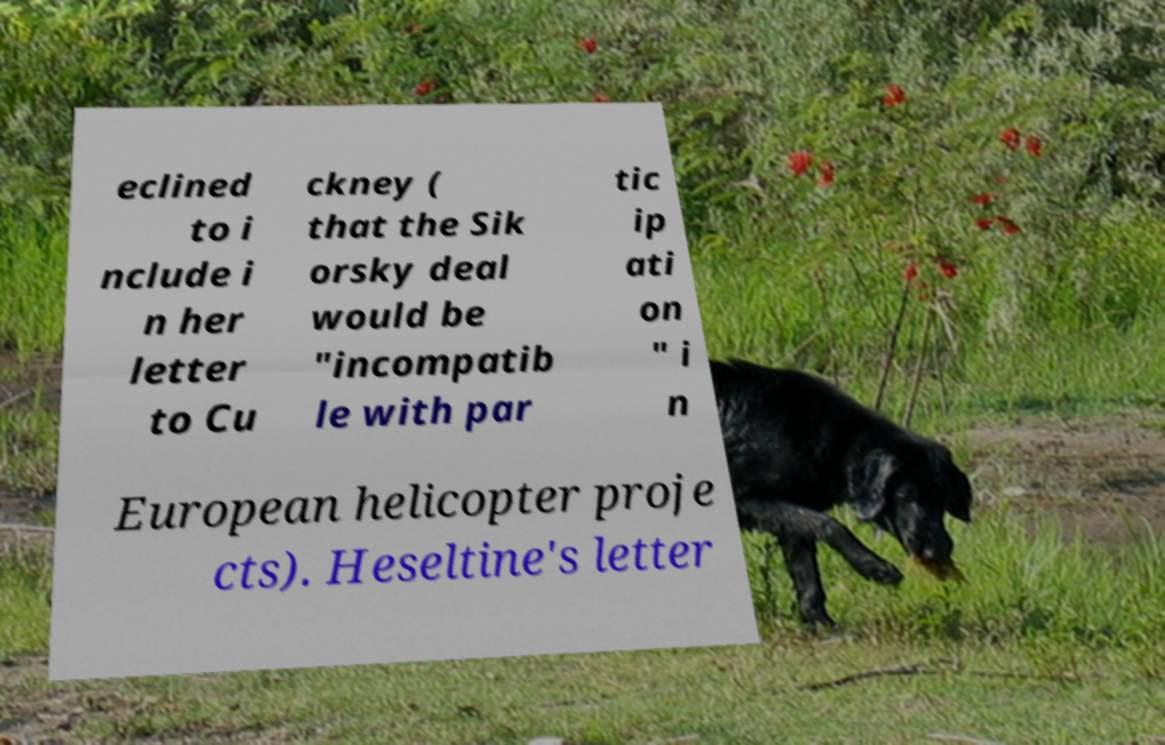There's text embedded in this image that I need extracted. Can you transcribe it verbatim? eclined to i nclude i n her letter to Cu ckney ( that the Sik orsky deal would be "incompatib le with par tic ip ati on " i n European helicopter proje cts). Heseltine's letter 